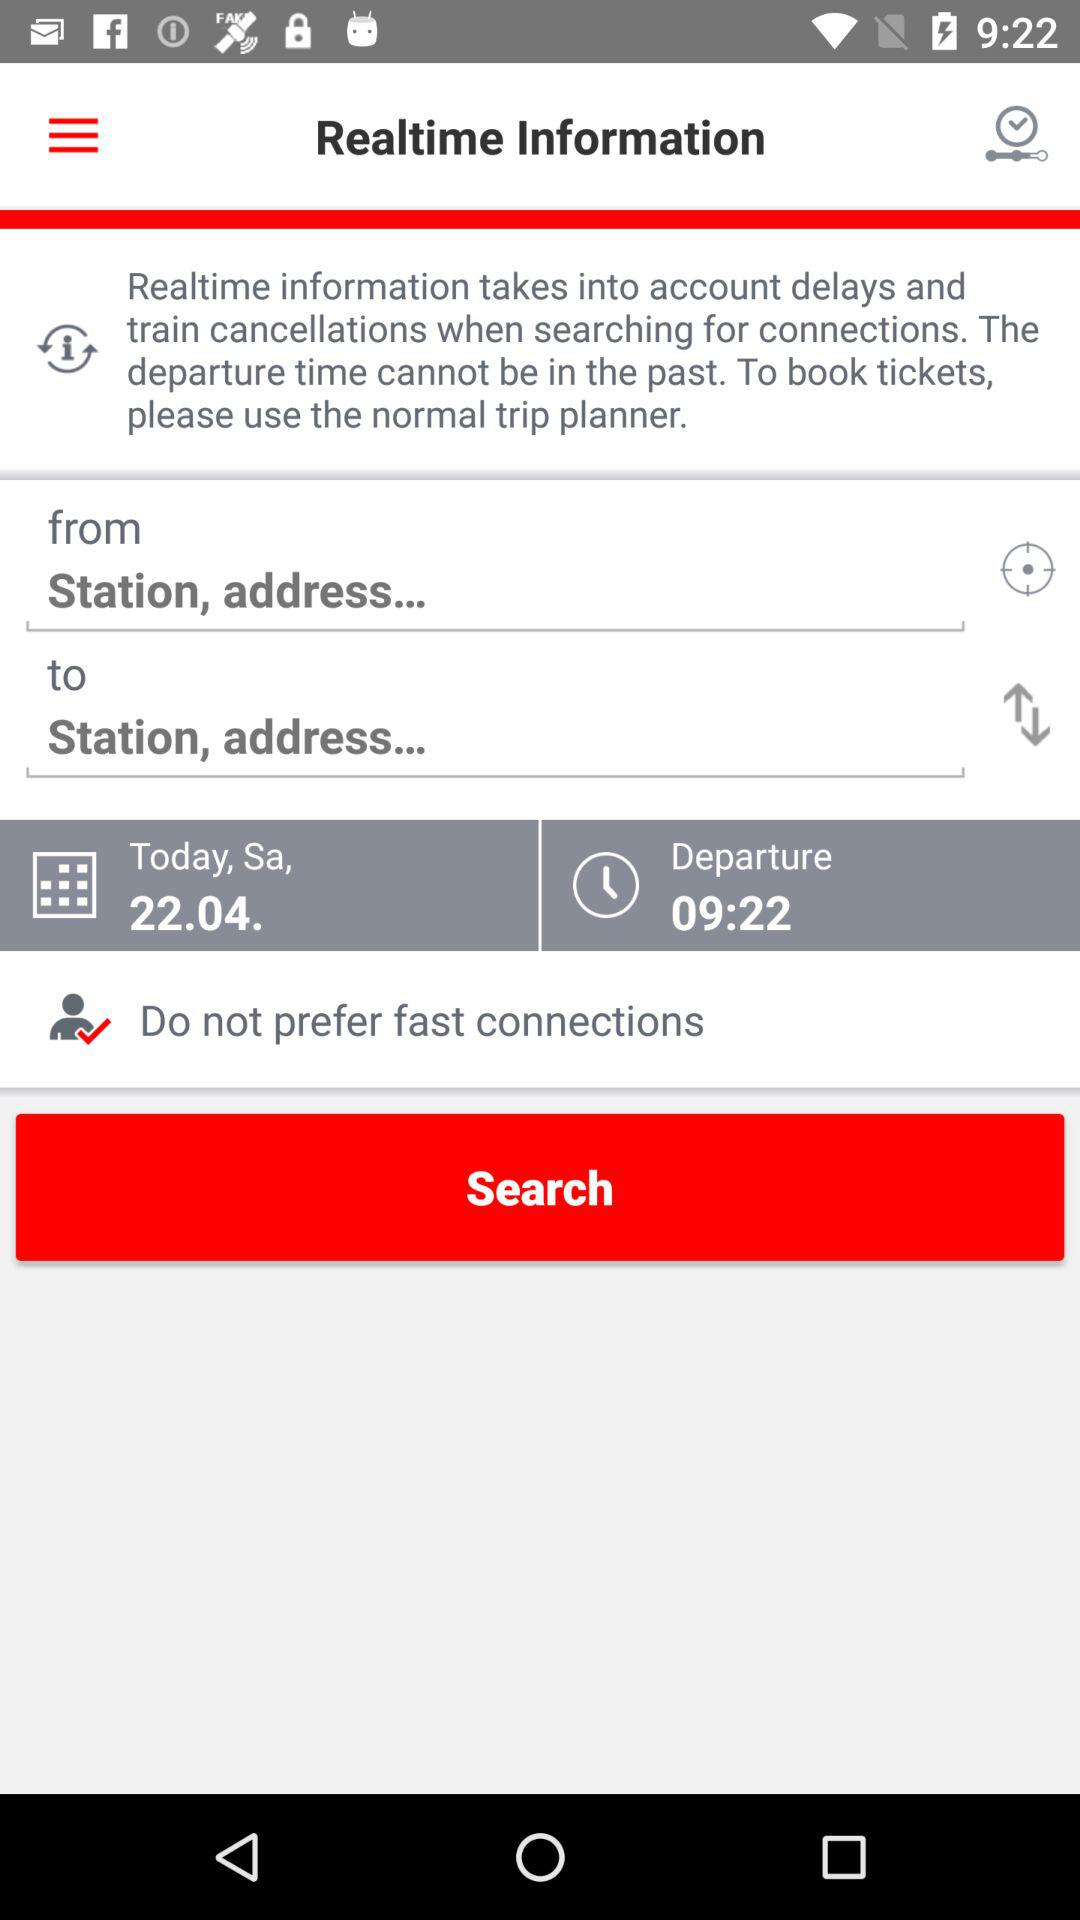What is today's date? Today's date is Saturday, April 22. 